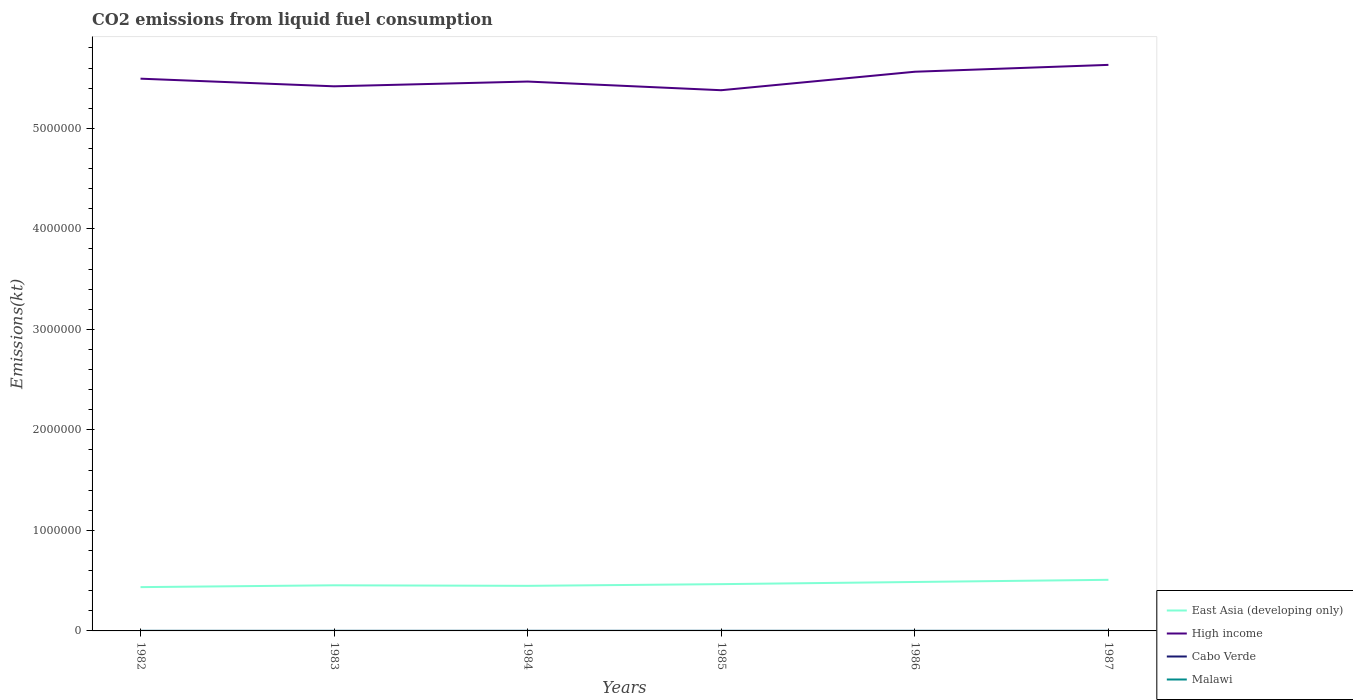How many different coloured lines are there?
Provide a succinct answer. 4. Does the line corresponding to Cabo Verde intersect with the line corresponding to East Asia (developing only)?
Your response must be concise. No. Across all years, what is the maximum amount of CO2 emitted in Cabo Verde?
Provide a short and direct response. 36.67. What is the total amount of CO2 emitted in East Asia (developing only) in the graph?
Make the answer very short. -1.28e+04. What is the difference between the highest and the second highest amount of CO2 emitted in Malawi?
Offer a very short reply. 36.67. What is the difference between the highest and the lowest amount of CO2 emitted in Malawi?
Offer a very short reply. 3. Is the amount of CO2 emitted in Cabo Verde strictly greater than the amount of CO2 emitted in Malawi over the years?
Provide a succinct answer. Yes. How many lines are there?
Give a very brief answer. 4. What is the difference between two consecutive major ticks on the Y-axis?
Give a very brief answer. 1.00e+06. How many legend labels are there?
Provide a succinct answer. 4. What is the title of the graph?
Provide a succinct answer. CO2 emissions from liquid fuel consumption. Does "Burundi" appear as one of the legend labels in the graph?
Provide a succinct answer. No. What is the label or title of the Y-axis?
Your answer should be compact. Emissions(kt). What is the Emissions(kt) of East Asia (developing only) in 1982?
Keep it short and to the point. 4.36e+05. What is the Emissions(kt) of High income in 1982?
Provide a short and direct response. 5.49e+06. What is the Emissions(kt) in Cabo Verde in 1982?
Offer a terse response. 36.67. What is the Emissions(kt) in Malawi in 1982?
Provide a succinct answer. 407.04. What is the Emissions(kt) of East Asia (developing only) in 1983?
Make the answer very short. 4.54e+05. What is the Emissions(kt) of High income in 1983?
Offer a very short reply. 5.42e+06. What is the Emissions(kt) in Cabo Verde in 1983?
Provide a short and direct response. 36.67. What is the Emissions(kt) of Malawi in 1983?
Provide a succinct answer. 421.7. What is the Emissions(kt) of East Asia (developing only) in 1984?
Offer a very short reply. 4.49e+05. What is the Emissions(kt) in High income in 1984?
Provide a succinct answer. 5.47e+06. What is the Emissions(kt) of Cabo Verde in 1984?
Your answer should be very brief. 84.34. What is the Emissions(kt) of Malawi in 1984?
Offer a very short reply. 410.7. What is the Emissions(kt) of East Asia (developing only) in 1985?
Offer a very short reply. 4.65e+05. What is the Emissions(kt) in High income in 1985?
Provide a succinct answer. 5.38e+06. What is the Emissions(kt) of Cabo Verde in 1985?
Your answer should be very brief. 84.34. What is the Emissions(kt) of Malawi in 1985?
Your answer should be compact. 443.71. What is the Emissions(kt) of East Asia (developing only) in 1986?
Your answer should be compact. 4.87e+05. What is the Emissions(kt) in High income in 1986?
Offer a very short reply. 5.56e+06. What is the Emissions(kt) in Cabo Verde in 1986?
Provide a short and direct response. 58.67. What is the Emissions(kt) of Malawi in 1986?
Your answer should be very brief. 443.71. What is the Emissions(kt) of East Asia (developing only) in 1987?
Your answer should be very brief. 5.08e+05. What is the Emissions(kt) of High income in 1987?
Provide a short and direct response. 5.63e+06. What is the Emissions(kt) in Cabo Verde in 1987?
Offer a terse response. 80.67. What is the Emissions(kt) in Malawi in 1987?
Offer a very short reply. 436.37. Across all years, what is the maximum Emissions(kt) of East Asia (developing only)?
Ensure brevity in your answer.  5.08e+05. Across all years, what is the maximum Emissions(kt) of High income?
Provide a succinct answer. 5.63e+06. Across all years, what is the maximum Emissions(kt) of Cabo Verde?
Keep it short and to the point. 84.34. Across all years, what is the maximum Emissions(kt) of Malawi?
Provide a short and direct response. 443.71. Across all years, what is the minimum Emissions(kt) of East Asia (developing only)?
Provide a succinct answer. 4.36e+05. Across all years, what is the minimum Emissions(kt) in High income?
Provide a succinct answer. 5.38e+06. Across all years, what is the minimum Emissions(kt) of Cabo Verde?
Your response must be concise. 36.67. Across all years, what is the minimum Emissions(kt) of Malawi?
Ensure brevity in your answer.  407.04. What is the total Emissions(kt) of East Asia (developing only) in the graph?
Your answer should be compact. 2.80e+06. What is the total Emissions(kt) in High income in the graph?
Your response must be concise. 3.30e+07. What is the total Emissions(kt) in Cabo Verde in the graph?
Offer a terse response. 381.37. What is the total Emissions(kt) of Malawi in the graph?
Ensure brevity in your answer.  2563.23. What is the difference between the Emissions(kt) of East Asia (developing only) in 1982 and that in 1983?
Your response must be concise. -1.83e+04. What is the difference between the Emissions(kt) of High income in 1982 and that in 1983?
Provide a succinct answer. 7.60e+04. What is the difference between the Emissions(kt) of Malawi in 1982 and that in 1983?
Make the answer very short. -14.67. What is the difference between the Emissions(kt) of East Asia (developing only) in 1982 and that in 1984?
Your answer should be compact. -1.28e+04. What is the difference between the Emissions(kt) in High income in 1982 and that in 1984?
Your response must be concise. 2.85e+04. What is the difference between the Emissions(kt) in Cabo Verde in 1982 and that in 1984?
Provide a succinct answer. -47.67. What is the difference between the Emissions(kt) in Malawi in 1982 and that in 1984?
Keep it short and to the point. -3.67. What is the difference between the Emissions(kt) of East Asia (developing only) in 1982 and that in 1985?
Provide a short and direct response. -2.97e+04. What is the difference between the Emissions(kt) in High income in 1982 and that in 1985?
Provide a succinct answer. 1.15e+05. What is the difference between the Emissions(kt) in Cabo Verde in 1982 and that in 1985?
Keep it short and to the point. -47.67. What is the difference between the Emissions(kt) in Malawi in 1982 and that in 1985?
Keep it short and to the point. -36.67. What is the difference between the Emissions(kt) of East Asia (developing only) in 1982 and that in 1986?
Offer a very short reply. -5.11e+04. What is the difference between the Emissions(kt) of High income in 1982 and that in 1986?
Your answer should be compact. -6.90e+04. What is the difference between the Emissions(kt) in Cabo Verde in 1982 and that in 1986?
Your answer should be compact. -22. What is the difference between the Emissions(kt) of Malawi in 1982 and that in 1986?
Your answer should be very brief. -36.67. What is the difference between the Emissions(kt) of East Asia (developing only) in 1982 and that in 1987?
Ensure brevity in your answer.  -7.27e+04. What is the difference between the Emissions(kt) of High income in 1982 and that in 1987?
Provide a short and direct response. -1.37e+05. What is the difference between the Emissions(kt) of Cabo Verde in 1982 and that in 1987?
Your answer should be very brief. -44. What is the difference between the Emissions(kt) of Malawi in 1982 and that in 1987?
Provide a succinct answer. -29.34. What is the difference between the Emissions(kt) of East Asia (developing only) in 1983 and that in 1984?
Provide a succinct answer. 5445.96. What is the difference between the Emissions(kt) in High income in 1983 and that in 1984?
Provide a succinct answer. -4.74e+04. What is the difference between the Emissions(kt) of Cabo Verde in 1983 and that in 1984?
Make the answer very short. -47.67. What is the difference between the Emissions(kt) in Malawi in 1983 and that in 1984?
Offer a very short reply. 11. What is the difference between the Emissions(kt) in East Asia (developing only) in 1983 and that in 1985?
Offer a very short reply. -1.14e+04. What is the difference between the Emissions(kt) of High income in 1983 and that in 1985?
Your answer should be compact. 3.88e+04. What is the difference between the Emissions(kt) in Cabo Verde in 1983 and that in 1985?
Your answer should be compact. -47.67. What is the difference between the Emissions(kt) in Malawi in 1983 and that in 1985?
Your response must be concise. -22. What is the difference between the Emissions(kt) in East Asia (developing only) in 1983 and that in 1986?
Your answer should be very brief. -3.28e+04. What is the difference between the Emissions(kt) of High income in 1983 and that in 1986?
Your answer should be very brief. -1.45e+05. What is the difference between the Emissions(kt) of Cabo Verde in 1983 and that in 1986?
Ensure brevity in your answer.  -22. What is the difference between the Emissions(kt) in Malawi in 1983 and that in 1986?
Your response must be concise. -22. What is the difference between the Emissions(kt) in East Asia (developing only) in 1983 and that in 1987?
Offer a terse response. -5.45e+04. What is the difference between the Emissions(kt) of High income in 1983 and that in 1987?
Ensure brevity in your answer.  -2.13e+05. What is the difference between the Emissions(kt) of Cabo Verde in 1983 and that in 1987?
Offer a terse response. -44. What is the difference between the Emissions(kt) in Malawi in 1983 and that in 1987?
Offer a very short reply. -14.67. What is the difference between the Emissions(kt) of East Asia (developing only) in 1984 and that in 1985?
Provide a succinct answer. -1.69e+04. What is the difference between the Emissions(kt) of High income in 1984 and that in 1985?
Offer a very short reply. 8.63e+04. What is the difference between the Emissions(kt) in Malawi in 1984 and that in 1985?
Offer a terse response. -33. What is the difference between the Emissions(kt) in East Asia (developing only) in 1984 and that in 1986?
Make the answer very short. -3.83e+04. What is the difference between the Emissions(kt) of High income in 1984 and that in 1986?
Provide a succinct answer. -9.76e+04. What is the difference between the Emissions(kt) of Cabo Verde in 1984 and that in 1986?
Make the answer very short. 25.67. What is the difference between the Emissions(kt) of Malawi in 1984 and that in 1986?
Ensure brevity in your answer.  -33. What is the difference between the Emissions(kt) of East Asia (developing only) in 1984 and that in 1987?
Offer a very short reply. -5.99e+04. What is the difference between the Emissions(kt) in High income in 1984 and that in 1987?
Offer a terse response. -1.66e+05. What is the difference between the Emissions(kt) of Cabo Verde in 1984 and that in 1987?
Give a very brief answer. 3.67. What is the difference between the Emissions(kt) of Malawi in 1984 and that in 1987?
Your answer should be compact. -25.67. What is the difference between the Emissions(kt) in East Asia (developing only) in 1985 and that in 1986?
Provide a short and direct response. -2.14e+04. What is the difference between the Emissions(kt) in High income in 1985 and that in 1986?
Provide a short and direct response. -1.84e+05. What is the difference between the Emissions(kt) of Cabo Verde in 1985 and that in 1986?
Make the answer very short. 25.67. What is the difference between the Emissions(kt) of East Asia (developing only) in 1985 and that in 1987?
Your response must be concise. -4.30e+04. What is the difference between the Emissions(kt) in High income in 1985 and that in 1987?
Your answer should be compact. -2.52e+05. What is the difference between the Emissions(kt) in Cabo Verde in 1985 and that in 1987?
Offer a terse response. 3.67. What is the difference between the Emissions(kt) in Malawi in 1985 and that in 1987?
Provide a short and direct response. 7.33. What is the difference between the Emissions(kt) in East Asia (developing only) in 1986 and that in 1987?
Make the answer very short. -2.16e+04. What is the difference between the Emissions(kt) in High income in 1986 and that in 1987?
Your answer should be compact. -6.82e+04. What is the difference between the Emissions(kt) of Cabo Verde in 1986 and that in 1987?
Keep it short and to the point. -22. What is the difference between the Emissions(kt) in Malawi in 1986 and that in 1987?
Make the answer very short. 7.33. What is the difference between the Emissions(kt) of East Asia (developing only) in 1982 and the Emissions(kt) of High income in 1983?
Offer a very short reply. -4.98e+06. What is the difference between the Emissions(kt) of East Asia (developing only) in 1982 and the Emissions(kt) of Cabo Verde in 1983?
Keep it short and to the point. 4.36e+05. What is the difference between the Emissions(kt) of East Asia (developing only) in 1982 and the Emissions(kt) of Malawi in 1983?
Your answer should be very brief. 4.35e+05. What is the difference between the Emissions(kt) of High income in 1982 and the Emissions(kt) of Cabo Verde in 1983?
Make the answer very short. 5.49e+06. What is the difference between the Emissions(kt) in High income in 1982 and the Emissions(kt) in Malawi in 1983?
Your answer should be very brief. 5.49e+06. What is the difference between the Emissions(kt) in Cabo Verde in 1982 and the Emissions(kt) in Malawi in 1983?
Offer a terse response. -385.04. What is the difference between the Emissions(kt) in East Asia (developing only) in 1982 and the Emissions(kt) in High income in 1984?
Keep it short and to the point. -5.03e+06. What is the difference between the Emissions(kt) of East Asia (developing only) in 1982 and the Emissions(kt) of Cabo Verde in 1984?
Keep it short and to the point. 4.36e+05. What is the difference between the Emissions(kt) in East Asia (developing only) in 1982 and the Emissions(kt) in Malawi in 1984?
Your answer should be compact. 4.35e+05. What is the difference between the Emissions(kt) in High income in 1982 and the Emissions(kt) in Cabo Verde in 1984?
Give a very brief answer. 5.49e+06. What is the difference between the Emissions(kt) in High income in 1982 and the Emissions(kt) in Malawi in 1984?
Provide a succinct answer. 5.49e+06. What is the difference between the Emissions(kt) in Cabo Verde in 1982 and the Emissions(kt) in Malawi in 1984?
Offer a terse response. -374.03. What is the difference between the Emissions(kt) in East Asia (developing only) in 1982 and the Emissions(kt) in High income in 1985?
Offer a very short reply. -4.94e+06. What is the difference between the Emissions(kt) in East Asia (developing only) in 1982 and the Emissions(kt) in Cabo Verde in 1985?
Provide a succinct answer. 4.36e+05. What is the difference between the Emissions(kt) of East Asia (developing only) in 1982 and the Emissions(kt) of Malawi in 1985?
Offer a terse response. 4.35e+05. What is the difference between the Emissions(kt) of High income in 1982 and the Emissions(kt) of Cabo Verde in 1985?
Give a very brief answer. 5.49e+06. What is the difference between the Emissions(kt) of High income in 1982 and the Emissions(kt) of Malawi in 1985?
Your answer should be very brief. 5.49e+06. What is the difference between the Emissions(kt) of Cabo Verde in 1982 and the Emissions(kt) of Malawi in 1985?
Provide a short and direct response. -407.04. What is the difference between the Emissions(kt) of East Asia (developing only) in 1982 and the Emissions(kt) of High income in 1986?
Your answer should be compact. -5.13e+06. What is the difference between the Emissions(kt) of East Asia (developing only) in 1982 and the Emissions(kt) of Cabo Verde in 1986?
Your response must be concise. 4.36e+05. What is the difference between the Emissions(kt) of East Asia (developing only) in 1982 and the Emissions(kt) of Malawi in 1986?
Make the answer very short. 4.35e+05. What is the difference between the Emissions(kt) of High income in 1982 and the Emissions(kt) of Cabo Verde in 1986?
Provide a succinct answer. 5.49e+06. What is the difference between the Emissions(kt) in High income in 1982 and the Emissions(kt) in Malawi in 1986?
Provide a succinct answer. 5.49e+06. What is the difference between the Emissions(kt) in Cabo Verde in 1982 and the Emissions(kt) in Malawi in 1986?
Offer a terse response. -407.04. What is the difference between the Emissions(kt) of East Asia (developing only) in 1982 and the Emissions(kt) of High income in 1987?
Your response must be concise. -5.20e+06. What is the difference between the Emissions(kt) in East Asia (developing only) in 1982 and the Emissions(kt) in Cabo Verde in 1987?
Your response must be concise. 4.36e+05. What is the difference between the Emissions(kt) of East Asia (developing only) in 1982 and the Emissions(kt) of Malawi in 1987?
Provide a succinct answer. 4.35e+05. What is the difference between the Emissions(kt) in High income in 1982 and the Emissions(kt) in Cabo Verde in 1987?
Your answer should be very brief. 5.49e+06. What is the difference between the Emissions(kt) of High income in 1982 and the Emissions(kt) of Malawi in 1987?
Keep it short and to the point. 5.49e+06. What is the difference between the Emissions(kt) of Cabo Verde in 1982 and the Emissions(kt) of Malawi in 1987?
Your answer should be very brief. -399.7. What is the difference between the Emissions(kt) of East Asia (developing only) in 1983 and the Emissions(kt) of High income in 1984?
Provide a succinct answer. -5.01e+06. What is the difference between the Emissions(kt) of East Asia (developing only) in 1983 and the Emissions(kt) of Cabo Verde in 1984?
Keep it short and to the point. 4.54e+05. What is the difference between the Emissions(kt) of East Asia (developing only) in 1983 and the Emissions(kt) of Malawi in 1984?
Keep it short and to the point. 4.54e+05. What is the difference between the Emissions(kt) of High income in 1983 and the Emissions(kt) of Cabo Verde in 1984?
Your answer should be very brief. 5.42e+06. What is the difference between the Emissions(kt) of High income in 1983 and the Emissions(kt) of Malawi in 1984?
Your response must be concise. 5.42e+06. What is the difference between the Emissions(kt) of Cabo Verde in 1983 and the Emissions(kt) of Malawi in 1984?
Provide a short and direct response. -374.03. What is the difference between the Emissions(kt) of East Asia (developing only) in 1983 and the Emissions(kt) of High income in 1985?
Ensure brevity in your answer.  -4.93e+06. What is the difference between the Emissions(kt) of East Asia (developing only) in 1983 and the Emissions(kt) of Cabo Verde in 1985?
Ensure brevity in your answer.  4.54e+05. What is the difference between the Emissions(kt) in East Asia (developing only) in 1983 and the Emissions(kt) in Malawi in 1985?
Provide a succinct answer. 4.54e+05. What is the difference between the Emissions(kt) of High income in 1983 and the Emissions(kt) of Cabo Verde in 1985?
Your answer should be very brief. 5.42e+06. What is the difference between the Emissions(kt) of High income in 1983 and the Emissions(kt) of Malawi in 1985?
Your answer should be compact. 5.42e+06. What is the difference between the Emissions(kt) in Cabo Verde in 1983 and the Emissions(kt) in Malawi in 1985?
Give a very brief answer. -407.04. What is the difference between the Emissions(kt) of East Asia (developing only) in 1983 and the Emissions(kt) of High income in 1986?
Give a very brief answer. -5.11e+06. What is the difference between the Emissions(kt) in East Asia (developing only) in 1983 and the Emissions(kt) in Cabo Verde in 1986?
Give a very brief answer. 4.54e+05. What is the difference between the Emissions(kt) in East Asia (developing only) in 1983 and the Emissions(kt) in Malawi in 1986?
Your answer should be very brief. 4.54e+05. What is the difference between the Emissions(kt) of High income in 1983 and the Emissions(kt) of Cabo Verde in 1986?
Your response must be concise. 5.42e+06. What is the difference between the Emissions(kt) of High income in 1983 and the Emissions(kt) of Malawi in 1986?
Your answer should be compact. 5.42e+06. What is the difference between the Emissions(kt) in Cabo Verde in 1983 and the Emissions(kt) in Malawi in 1986?
Offer a terse response. -407.04. What is the difference between the Emissions(kt) in East Asia (developing only) in 1983 and the Emissions(kt) in High income in 1987?
Your response must be concise. -5.18e+06. What is the difference between the Emissions(kt) in East Asia (developing only) in 1983 and the Emissions(kt) in Cabo Verde in 1987?
Your answer should be compact. 4.54e+05. What is the difference between the Emissions(kt) of East Asia (developing only) in 1983 and the Emissions(kt) of Malawi in 1987?
Offer a very short reply. 4.54e+05. What is the difference between the Emissions(kt) of High income in 1983 and the Emissions(kt) of Cabo Verde in 1987?
Provide a succinct answer. 5.42e+06. What is the difference between the Emissions(kt) of High income in 1983 and the Emissions(kt) of Malawi in 1987?
Offer a terse response. 5.42e+06. What is the difference between the Emissions(kt) in Cabo Verde in 1983 and the Emissions(kt) in Malawi in 1987?
Make the answer very short. -399.7. What is the difference between the Emissions(kt) in East Asia (developing only) in 1984 and the Emissions(kt) in High income in 1985?
Offer a very short reply. -4.93e+06. What is the difference between the Emissions(kt) of East Asia (developing only) in 1984 and the Emissions(kt) of Cabo Verde in 1985?
Your answer should be very brief. 4.48e+05. What is the difference between the Emissions(kt) in East Asia (developing only) in 1984 and the Emissions(kt) in Malawi in 1985?
Keep it short and to the point. 4.48e+05. What is the difference between the Emissions(kt) in High income in 1984 and the Emissions(kt) in Cabo Verde in 1985?
Keep it short and to the point. 5.47e+06. What is the difference between the Emissions(kt) in High income in 1984 and the Emissions(kt) in Malawi in 1985?
Your response must be concise. 5.47e+06. What is the difference between the Emissions(kt) in Cabo Verde in 1984 and the Emissions(kt) in Malawi in 1985?
Offer a terse response. -359.37. What is the difference between the Emissions(kt) in East Asia (developing only) in 1984 and the Emissions(kt) in High income in 1986?
Provide a short and direct response. -5.11e+06. What is the difference between the Emissions(kt) of East Asia (developing only) in 1984 and the Emissions(kt) of Cabo Verde in 1986?
Offer a very short reply. 4.48e+05. What is the difference between the Emissions(kt) of East Asia (developing only) in 1984 and the Emissions(kt) of Malawi in 1986?
Your answer should be very brief. 4.48e+05. What is the difference between the Emissions(kt) in High income in 1984 and the Emissions(kt) in Cabo Verde in 1986?
Give a very brief answer. 5.47e+06. What is the difference between the Emissions(kt) in High income in 1984 and the Emissions(kt) in Malawi in 1986?
Your response must be concise. 5.47e+06. What is the difference between the Emissions(kt) in Cabo Verde in 1984 and the Emissions(kt) in Malawi in 1986?
Offer a terse response. -359.37. What is the difference between the Emissions(kt) in East Asia (developing only) in 1984 and the Emissions(kt) in High income in 1987?
Offer a terse response. -5.18e+06. What is the difference between the Emissions(kt) in East Asia (developing only) in 1984 and the Emissions(kt) in Cabo Verde in 1987?
Provide a succinct answer. 4.48e+05. What is the difference between the Emissions(kt) of East Asia (developing only) in 1984 and the Emissions(kt) of Malawi in 1987?
Provide a short and direct response. 4.48e+05. What is the difference between the Emissions(kt) of High income in 1984 and the Emissions(kt) of Cabo Verde in 1987?
Ensure brevity in your answer.  5.47e+06. What is the difference between the Emissions(kt) in High income in 1984 and the Emissions(kt) in Malawi in 1987?
Ensure brevity in your answer.  5.47e+06. What is the difference between the Emissions(kt) of Cabo Verde in 1984 and the Emissions(kt) of Malawi in 1987?
Give a very brief answer. -352.03. What is the difference between the Emissions(kt) in East Asia (developing only) in 1985 and the Emissions(kt) in High income in 1986?
Your answer should be very brief. -5.10e+06. What is the difference between the Emissions(kt) in East Asia (developing only) in 1985 and the Emissions(kt) in Cabo Verde in 1986?
Offer a terse response. 4.65e+05. What is the difference between the Emissions(kt) in East Asia (developing only) in 1985 and the Emissions(kt) in Malawi in 1986?
Keep it short and to the point. 4.65e+05. What is the difference between the Emissions(kt) of High income in 1985 and the Emissions(kt) of Cabo Verde in 1986?
Ensure brevity in your answer.  5.38e+06. What is the difference between the Emissions(kt) of High income in 1985 and the Emissions(kt) of Malawi in 1986?
Ensure brevity in your answer.  5.38e+06. What is the difference between the Emissions(kt) of Cabo Verde in 1985 and the Emissions(kt) of Malawi in 1986?
Offer a terse response. -359.37. What is the difference between the Emissions(kt) of East Asia (developing only) in 1985 and the Emissions(kt) of High income in 1987?
Make the answer very short. -5.17e+06. What is the difference between the Emissions(kt) in East Asia (developing only) in 1985 and the Emissions(kt) in Cabo Verde in 1987?
Offer a very short reply. 4.65e+05. What is the difference between the Emissions(kt) of East Asia (developing only) in 1985 and the Emissions(kt) of Malawi in 1987?
Your response must be concise. 4.65e+05. What is the difference between the Emissions(kt) in High income in 1985 and the Emissions(kt) in Cabo Verde in 1987?
Offer a terse response. 5.38e+06. What is the difference between the Emissions(kt) of High income in 1985 and the Emissions(kt) of Malawi in 1987?
Give a very brief answer. 5.38e+06. What is the difference between the Emissions(kt) in Cabo Verde in 1985 and the Emissions(kt) in Malawi in 1987?
Keep it short and to the point. -352.03. What is the difference between the Emissions(kt) in East Asia (developing only) in 1986 and the Emissions(kt) in High income in 1987?
Make the answer very short. -5.14e+06. What is the difference between the Emissions(kt) of East Asia (developing only) in 1986 and the Emissions(kt) of Cabo Verde in 1987?
Your response must be concise. 4.87e+05. What is the difference between the Emissions(kt) in East Asia (developing only) in 1986 and the Emissions(kt) in Malawi in 1987?
Ensure brevity in your answer.  4.86e+05. What is the difference between the Emissions(kt) of High income in 1986 and the Emissions(kt) of Cabo Verde in 1987?
Provide a short and direct response. 5.56e+06. What is the difference between the Emissions(kt) in High income in 1986 and the Emissions(kt) in Malawi in 1987?
Your answer should be very brief. 5.56e+06. What is the difference between the Emissions(kt) of Cabo Verde in 1986 and the Emissions(kt) of Malawi in 1987?
Provide a succinct answer. -377.7. What is the average Emissions(kt) in East Asia (developing only) per year?
Your answer should be very brief. 4.66e+05. What is the average Emissions(kt) of High income per year?
Your answer should be compact. 5.49e+06. What is the average Emissions(kt) of Cabo Verde per year?
Give a very brief answer. 63.56. What is the average Emissions(kt) of Malawi per year?
Your response must be concise. 427.21. In the year 1982, what is the difference between the Emissions(kt) in East Asia (developing only) and Emissions(kt) in High income?
Your answer should be very brief. -5.06e+06. In the year 1982, what is the difference between the Emissions(kt) of East Asia (developing only) and Emissions(kt) of Cabo Verde?
Offer a terse response. 4.36e+05. In the year 1982, what is the difference between the Emissions(kt) in East Asia (developing only) and Emissions(kt) in Malawi?
Offer a terse response. 4.35e+05. In the year 1982, what is the difference between the Emissions(kt) of High income and Emissions(kt) of Cabo Verde?
Ensure brevity in your answer.  5.49e+06. In the year 1982, what is the difference between the Emissions(kt) in High income and Emissions(kt) in Malawi?
Keep it short and to the point. 5.49e+06. In the year 1982, what is the difference between the Emissions(kt) of Cabo Verde and Emissions(kt) of Malawi?
Ensure brevity in your answer.  -370.37. In the year 1983, what is the difference between the Emissions(kt) in East Asia (developing only) and Emissions(kt) in High income?
Provide a short and direct response. -4.96e+06. In the year 1983, what is the difference between the Emissions(kt) of East Asia (developing only) and Emissions(kt) of Cabo Verde?
Ensure brevity in your answer.  4.54e+05. In the year 1983, what is the difference between the Emissions(kt) of East Asia (developing only) and Emissions(kt) of Malawi?
Your response must be concise. 4.54e+05. In the year 1983, what is the difference between the Emissions(kt) of High income and Emissions(kt) of Cabo Verde?
Offer a very short reply. 5.42e+06. In the year 1983, what is the difference between the Emissions(kt) in High income and Emissions(kt) in Malawi?
Keep it short and to the point. 5.42e+06. In the year 1983, what is the difference between the Emissions(kt) in Cabo Verde and Emissions(kt) in Malawi?
Provide a succinct answer. -385.04. In the year 1984, what is the difference between the Emissions(kt) of East Asia (developing only) and Emissions(kt) of High income?
Give a very brief answer. -5.02e+06. In the year 1984, what is the difference between the Emissions(kt) of East Asia (developing only) and Emissions(kt) of Cabo Verde?
Provide a short and direct response. 4.48e+05. In the year 1984, what is the difference between the Emissions(kt) in East Asia (developing only) and Emissions(kt) in Malawi?
Your answer should be very brief. 4.48e+05. In the year 1984, what is the difference between the Emissions(kt) of High income and Emissions(kt) of Cabo Verde?
Offer a very short reply. 5.47e+06. In the year 1984, what is the difference between the Emissions(kt) in High income and Emissions(kt) in Malawi?
Your answer should be very brief. 5.47e+06. In the year 1984, what is the difference between the Emissions(kt) in Cabo Verde and Emissions(kt) in Malawi?
Your answer should be very brief. -326.36. In the year 1985, what is the difference between the Emissions(kt) in East Asia (developing only) and Emissions(kt) in High income?
Provide a short and direct response. -4.91e+06. In the year 1985, what is the difference between the Emissions(kt) of East Asia (developing only) and Emissions(kt) of Cabo Verde?
Offer a terse response. 4.65e+05. In the year 1985, what is the difference between the Emissions(kt) in East Asia (developing only) and Emissions(kt) in Malawi?
Offer a terse response. 4.65e+05. In the year 1985, what is the difference between the Emissions(kt) in High income and Emissions(kt) in Cabo Verde?
Keep it short and to the point. 5.38e+06. In the year 1985, what is the difference between the Emissions(kt) in High income and Emissions(kt) in Malawi?
Your response must be concise. 5.38e+06. In the year 1985, what is the difference between the Emissions(kt) in Cabo Verde and Emissions(kt) in Malawi?
Make the answer very short. -359.37. In the year 1986, what is the difference between the Emissions(kt) of East Asia (developing only) and Emissions(kt) of High income?
Provide a succinct answer. -5.08e+06. In the year 1986, what is the difference between the Emissions(kt) of East Asia (developing only) and Emissions(kt) of Cabo Verde?
Your answer should be very brief. 4.87e+05. In the year 1986, what is the difference between the Emissions(kt) in East Asia (developing only) and Emissions(kt) in Malawi?
Your response must be concise. 4.86e+05. In the year 1986, what is the difference between the Emissions(kt) in High income and Emissions(kt) in Cabo Verde?
Provide a short and direct response. 5.56e+06. In the year 1986, what is the difference between the Emissions(kt) of High income and Emissions(kt) of Malawi?
Your answer should be very brief. 5.56e+06. In the year 1986, what is the difference between the Emissions(kt) of Cabo Verde and Emissions(kt) of Malawi?
Make the answer very short. -385.04. In the year 1987, what is the difference between the Emissions(kt) in East Asia (developing only) and Emissions(kt) in High income?
Keep it short and to the point. -5.12e+06. In the year 1987, what is the difference between the Emissions(kt) of East Asia (developing only) and Emissions(kt) of Cabo Verde?
Make the answer very short. 5.08e+05. In the year 1987, what is the difference between the Emissions(kt) in East Asia (developing only) and Emissions(kt) in Malawi?
Offer a very short reply. 5.08e+05. In the year 1987, what is the difference between the Emissions(kt) of High income and Emissions(kt) of Cabo Verde?
Ensure brevity in your answer.  5.63e+06. In the year 1987, what is the difference between the Emissions(kt) of High income and Emissions(kt) of Malawi?
Ensure brevity in your answer.  5.63e+06. In the year 1987, what is the difference between the Emissions(kt) in Cabo Verde and Emissions(kt) in Malawi?
Make the answer very short. -355.7. What is the ratio of the Emissions(kt) of East Asia (developing only) in 1982 to that in 1983?
Offer a terse response. 0.96. What is the ratio of the Emissions(kt) of High income in 1982 to that in 1983?
Provide a succinct answer. 1.01. What is the ratio of the Emissions(kt) in Malawi in 1982 to that in 1983?
Provide a succinct answer. 0.97. What is the ratio of the Emissions(kt) of East Asia (developing only) in 1982 to that in 1984?
Make the answer very short. 0.97. What is the ratio of the Emissions(kt) in Cabo Verde in 1982 to that in 1984?
Offer a terse response. 0.43. What is the ratio of the Emissions(kt) in East Asia (developing only) in 1982 to that in 1985?
Your response must be concise. 0.94. What is the ratio of the Emissions(kt) in High income in 1982 to that in 1985?
Your answer should be compact. 1.02. What is the ratio of the Emissions(kt) of Cabo Verde in 1982 to that in 1985?
Keep it short and to the point. 0.43. What is the ratio of the Emissions(kt) in Malawi in 1982 to that in 1985?
Offer a very short reply. 0.92. What is the ratio of the Emissions(kt) of East Asia (developing only) in 1982 to that in 1986?
Your answer should be very brief. 0.9. What is the ratio of the Emissions(kt) of High income in 1982 to that in 1986?
Give a very brief answer. 0.99. What is the ratio of the Emissions(kt) of Malawi in 1982 to that in 1986?
Offer a terse response. 0.92. What is the ratio of the Emissions(kt) of East Asia (developing only) in 1982 to that in 1987?
Keep it short and to the point. 0.86. What is the ratio of the Emissions(kt) in High income in 1982 to that in 1987?
Make the answer very short. 0.98. What is the ratio of the Emissions(kt) of Cabo Verde in 1982 to that in 1987?
Give a very brief answer. 0.45. What is the ratio of the Emissions(kt) of Malawi in 1982 to that in 1987?
Provide a short and direct response. 0.93. What is the ratio of the Emissions(kt) of East Asia (developing only) in 1983 to that in 1984?
Make the answer very short. 1.01. What is the ratio of the Emissions(kt) of High income in 1983 to that in 1984?
Give a very brief answer. 0.99. What is the ratio of the Emissions(kt) in Cabo Verde in 1983 to that in 1984?
Your response must be concise. 0.43. What is the ratio of the Emissions(kt) of Malawi in 1983 to that in 1984?
Your answer should be compact. 1.03. What is the ratio of the Emissions(kt) in East Asia (developing only) in 1983 to that in 1985?
Offer a terse response. 0.98. What is the ratio of the Emissions(kt) in Cabo Verde in 1983 to that in 1985?
Give a very brief answer. 0.43. What is the ratio of the Emissions(kt) in Malawi in 1983 to that in 1985?
Your answer should be compact. 0.95. What is the ratio of the Emissions(kt) of East Asia (developing only) in 1983 to that in 1986?
Ensure brevity in your answer.  0.93. What is the ratio of the Emissions(kt) of High income in 1983 to that in 1986?
Offer a very short reply. 0.97. What is the ratio of the Emissions(kt) of Malawi in 1983 to that in 1986?
Your answer should be very brief. 0.95. What is the ratio of the Emissions(kt) of East Asia (developing only) in 1983 to that in 1987?
Offer a terse response. 0.89. What is the ratio of the Emissions(kt) of High income in 1983 to that in 1987?
Provide a succinct answer. 0.96. What is the ratio of the Emissions(kt) of Cabo Verde in 1983 to that in 1987?
Give a very brief answer. 0.45. What is the ratio of the Emissions(kt) in Malawi in 1983 to that in 1987?
Your answer should be very brief. 0.97. What is the ratio of the Emissions(kt) in East Asia (developing only) in 1984 to that in 1985?
Give a very brief answer. 0.96. What is the ratio of the Emissions(kt) in High income in 1984 to that in 1985?
Ensure brevity in your answer.  1.02. What is the ratio of the Emissions(kt) of Cabo Verde in 1984 to that in 1985?
Offer a terse response. 1. What is the ratio of the Emissions(kt) in Malawi in 1984 to that in 1985?
Give a very brief answer. 0.93. What is the ratio of the Emissions(kt) in East Asia (developing only) in 1984 to that in 1986?
Provide a succinct answer. 0.92. What is the ratio of the Emissions(kt) in High income in 1984 to that in 1986?
Ensure brevity in your answer.  0.98. What is the ratio of the Emissions(kt) in Cabo Verde in 1984 to that in 1986?
Ensure brevity in your answer.  1.44. What is the ratio of the Emissions(kt) of Malawi in 1984 to that in 1986?
Make the answer very short. 0.93. What is the ratio of the Emissions(kt) of East Asia (developing only) in 1984 to that in 1987?
Your response must be concise. 0.88. What is the ratio of the Emissions(kt) of High income in 1984 to that in 1987?
Offer a very short reply. 0.97. What is the ratio of the Emissions(kt) of Cabo Verde in 1984 to that in 1987?
Your response must be concise. 1.05. What is the ratio of the Emissions(kt) of East Asia (developing only) in 1985 to that in 1986?
Give a very brief answer. 0.96. What is the ratio of the Emissions(kt) in Cabo Verde in 1985 to that in 1986?
Provide a succinct answer. 1.44. What is the ratio of the Emissions(kt) of East Asia (developing only) in 1985 to that in 1987?
Offer a very short reply. 0.92. What is the ratio of the Emissions(kt) of High income in 1985 to that in 1987?
Your response must be concise. 0.96. What is the ratio of the Emissions(kt) of Cabo Verde in 1985 to that in 1987?
Your response must be concise. 1.05. What is the ratio of the Emissions(kt) of Malawi in 1985 to that in 1987?
Provide a succinct answer. 1.02. What is the ratio of the Emissions(kt) in East Asia (developing only) in 1986 to that in 1987?
Your answer should be very brief. 0.96. What is the ratio of the Emissions(kt) in High income in 1986 to that in 1987?
Provide a short and direct response. 0.99. What is the ratio of the Emissions(kt) of Cabo Verde in 1986 to that in 1987?
Offer a terse response. 0.73. What is the ratio of the Emissions(kt) in Malawi in 1986 to that in 1987?
Make the answer very short. 1.02. What is the difference between the highest and the second highest Emissions(kt) in East Asia (developing only)?
Your response must be concise. 2.16e+04. What is the difference between the highest and the second highest Emissions(kt) in High income?
Your response must be concise. 6.82e+04. What is the difference between the highest and the second highest Emissions(kt) of Malawi?
Keep it short and to the point. 0. What is the difference between the highest and the lowest Emissions(kt) in East Asia (developing only)?
Your response must be concise. 7.27e+04. What is the difference between the highest and the lowest Emissions(kt) of High income?
Your answer should be very brief. 2.52e+05. What is the difference between the highest and the lowest Emissions(kt) of Cabo Verde?
Keep it short and to the point. 47.67. What is the difference between the highest and the lowest Emissions(kt) of Malawi?
Keep it short and to the point. 36.67. 